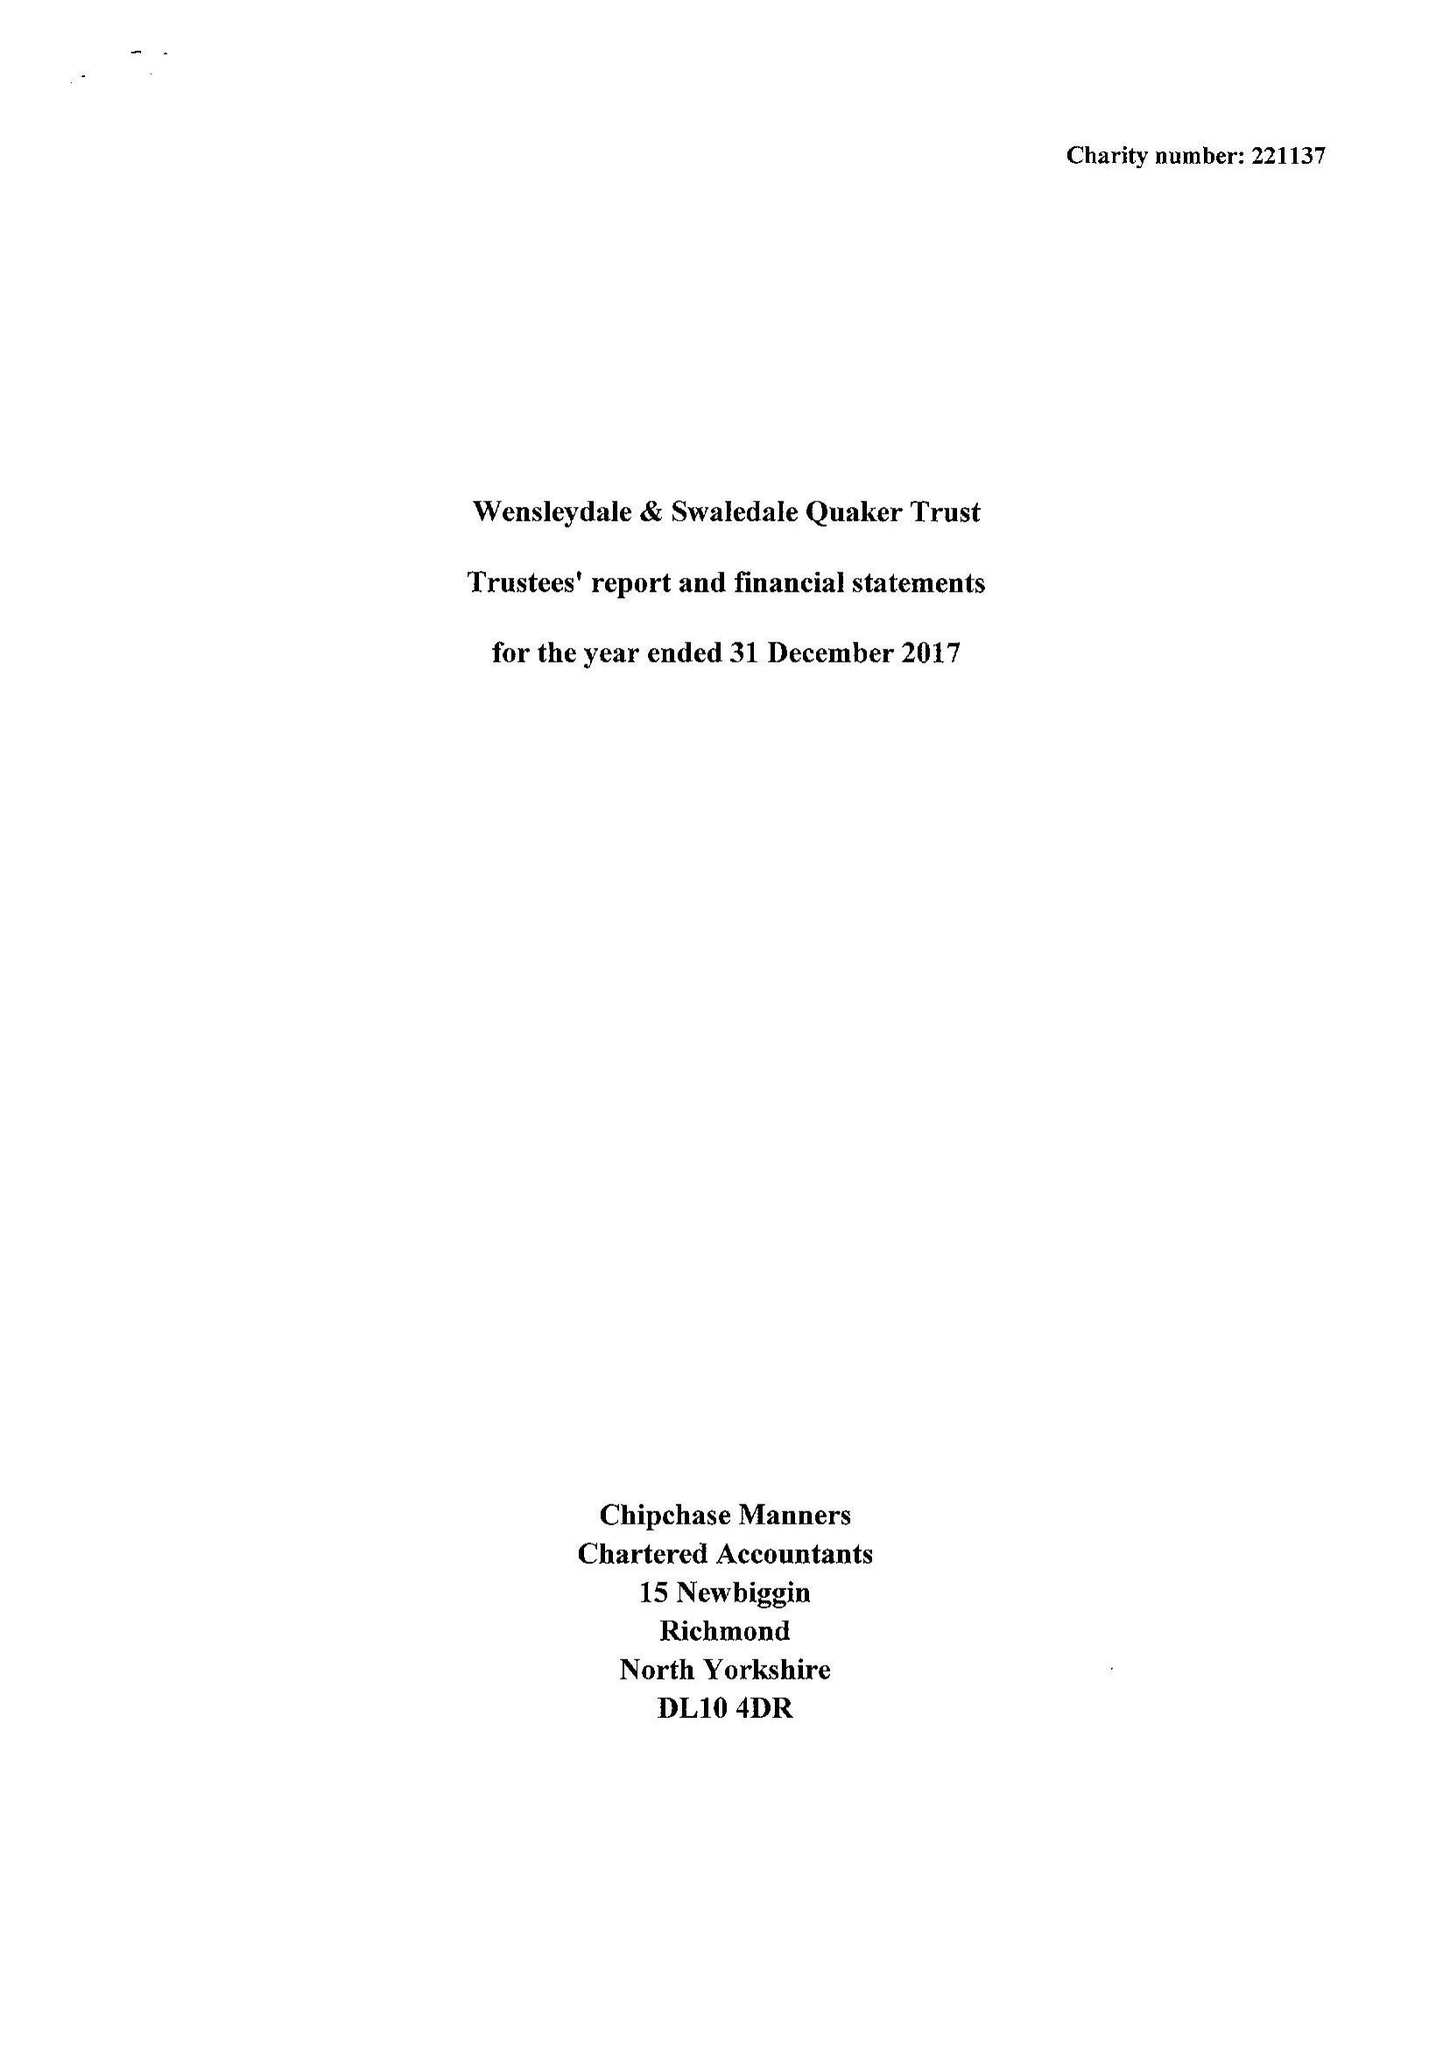What is the value for the charity_number?
Answer the question using a single word or phrase. 221137 